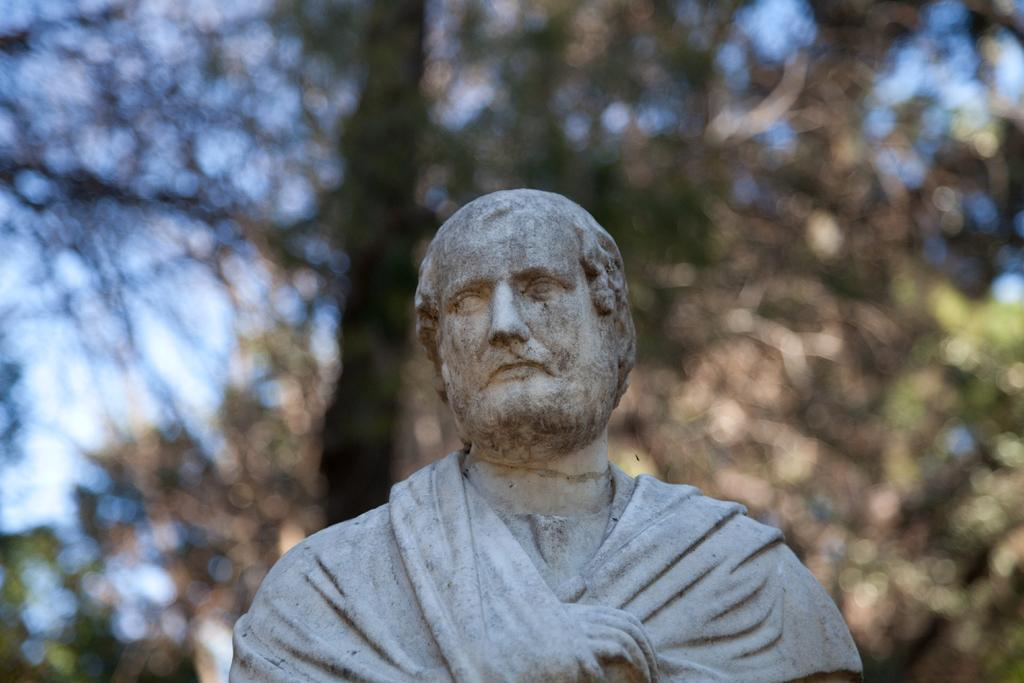What is the main subject of the image? There is a statue in the image. What can be seen in the background of the image? There are trees in the background of the image. What type of fruit is hanging from the branches of the trees in the image? There is no fruit visible in the image; only the statue and trees are present. What is the weight of the statue in the image? The weight of the statue cannot be determined from the image alone. 